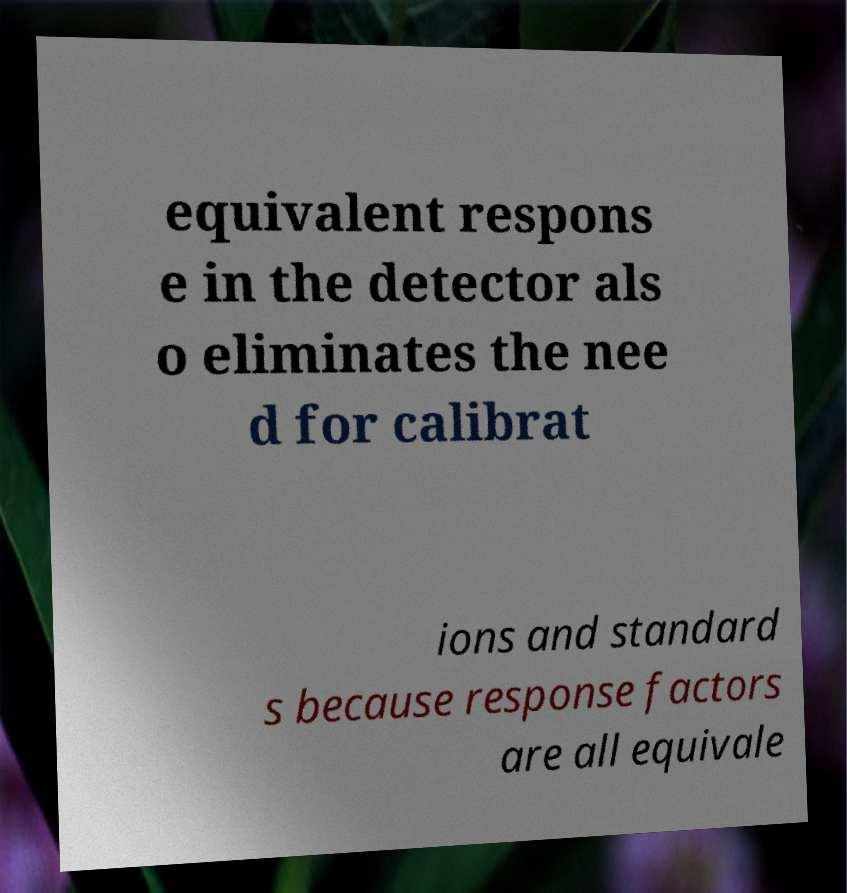Can you accurately transcribe the text from the provided image for me? equivalent respons e in the detector als o eliminates the nee d for calibrat ions and standard s because response factors are all equivale 